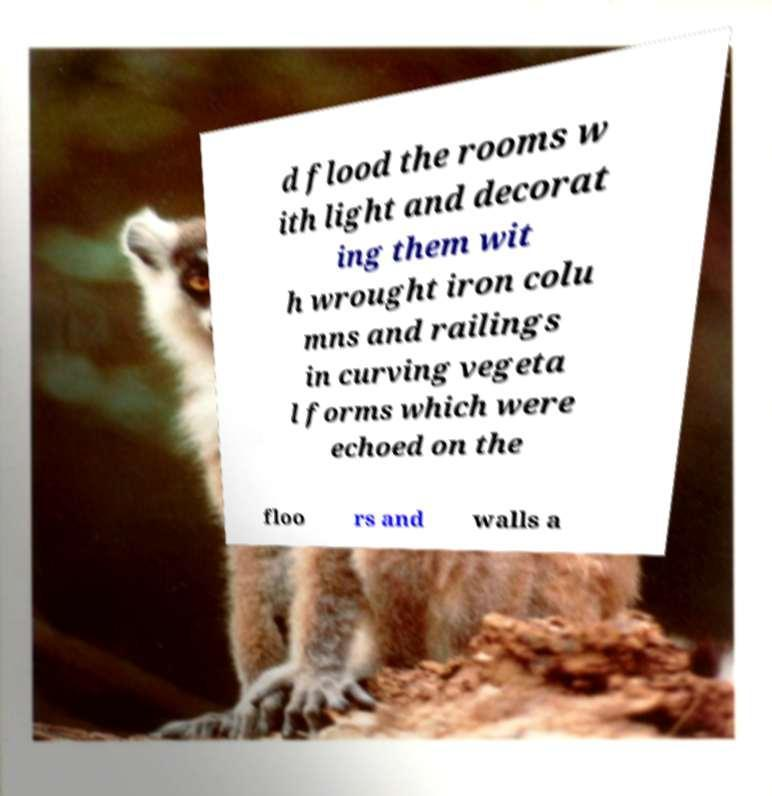Could you extract and type out the text from this image? d flood the rooms w ith light and decorat ing them wit h wrought iron colu mns and railings in curving vegeta l forms which were echoed on the floo rs and walls a 